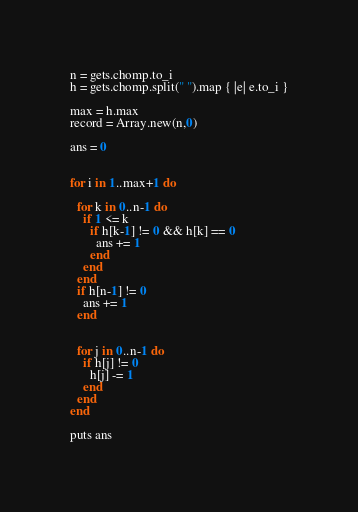<code> <loc_0><loc_0><loc_500><loc_500><_Ruby_>n = gets.chomp.to_i
h = gets.chomp.split(" ").map { |e| e.to_i }

max = h.max
record = Array.new(n,0)

ans = 0


for i in 1..max+1 do

  for k in 0..n-1 do
    if 1 <= k
      if h[k-1] != 0 && h[k] == 0
        ans += 1
      end
    end
  end
  if h[n-1] != 0
    ans += 1
  end


  for j in 0..n-1 do
    if h[j] != 0
      h[j] -= 1
    end
  end
end

puts ans
</code> 